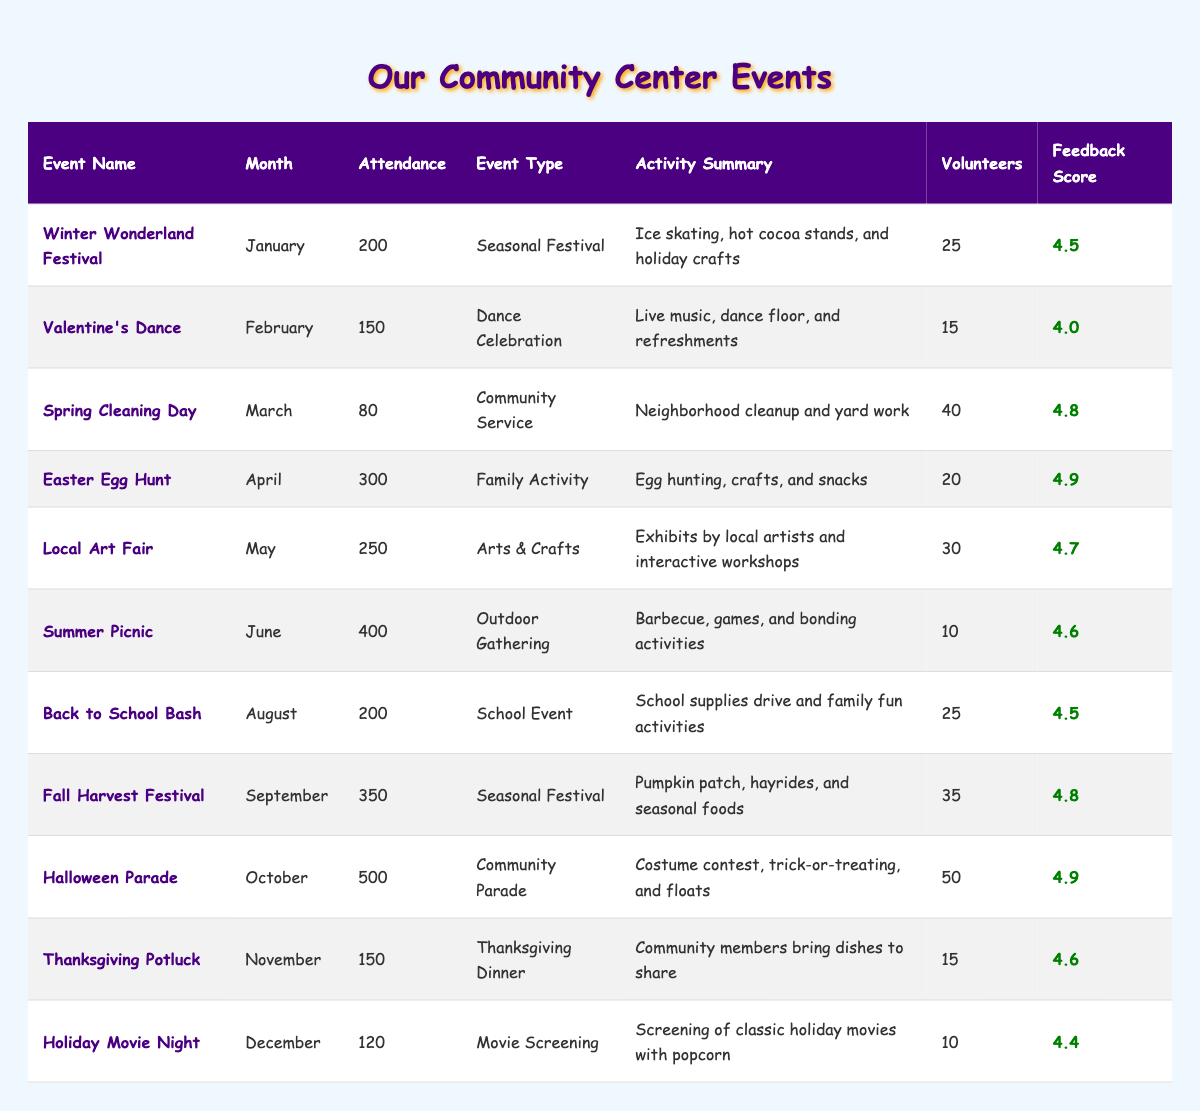What was the highest attendance at an event? The table shows the attendance for each event. The highest number is 500 at the Halloween Parade in October.
Answer: 500 Which event had the most volunteers? The table lists the number of volunteers for each event. The Halloween Parade had the highest number of volunteers with 50.
Answer: 50 How many events took place in the summer months? The summer months are June to August. The events during these months are the Summer Picnic (June), Back to School Bash (August), so there are 2 events.
Answer: 2 What is the total attendance for all events in the year? To find the total attendance, we sum the attendance numbers for all events: 200 + 150 + 80 + 300 + 250 + 400 + 200 + 350 + 500 + 150 + 120 = 2800.
Answer: 2800 What is the average feedback score across all events? To calculate the average feedback score, we first sum the scores: 4.5 + 4.0 + 4.8 + 4.9 + 4.7 + 4.6 + 4.5 + 4.8 + 4.9 + 4.6 + 4.4 = 52.5. There are 11 events, so the average is 52.5 / 11 = 4.77.
Answer: 4.77 Was the Valentine's Dance better rated than the Thanksgiving Potluck? The feedback score for the Valentine's Dance is 4.0 and for the Thanksgiving Potluck is 4.6. Since 4.0 is less than 4.6, the Valentine's Dance was not better rated.
Answer: No What type of event had the highest attendance? The event type with the highest attendance was the Community Parade, specifically the Halloween Parade, which had 500 attendees.
Answer: Community Parade In which month did the event with the least attendance occur? The event with the least attendance is Spring Cleaning Day with 80 attendees, occurring in March.
Answer: March How many events received a feedback score of 4.8 or higher? Counting the events with scores of 4.8 or higher: Spring Cleaning Day (4.8), Easter Egg Hunt (4.9), Local Art Fair (4.7), Summer Picnic (4.6), Fall Harvest Festival (4.8), Halloween Parade (4.9), and Thanksgiving Potluck (4.6) totals 6 events.
Answer: 6 What month had the Easter Egg Hunt? The Easter Egg Hunt was held in April.
Answer: April Did any event in November have a higher attendance than the one in January? The Thanksgiving Potluck in November had 150 attendees, while the Winter Wonderland Festival in January had 200 attendees. Since 150 is less than 200, no event in November had higher attendance than in January.
Answer: No 